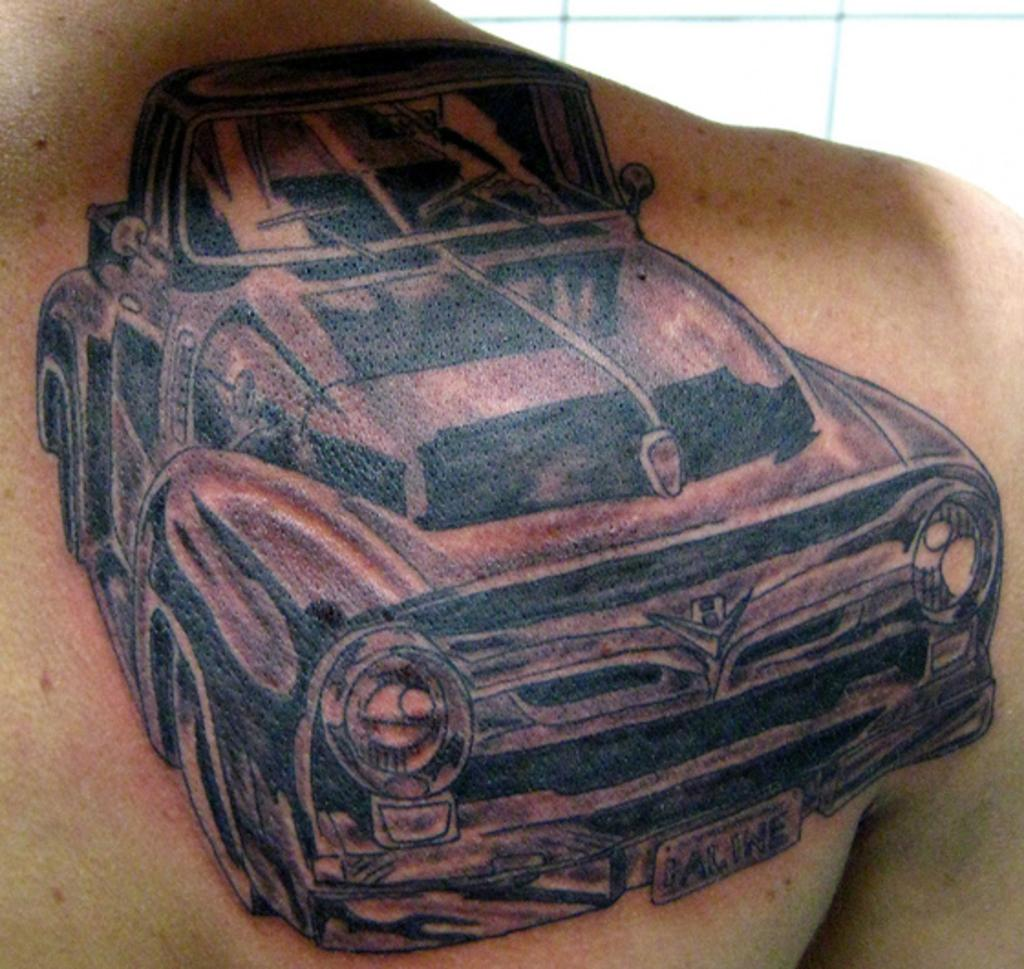What is depicted as a tattoo on the person in the image? There is a tattoo of a car on the back of the person in the image. How much does the owner of the car feel anger in the image? There is no indication of the owner of the car or any emotions in the image, as it only features a tattoo of a car on a person's back. 